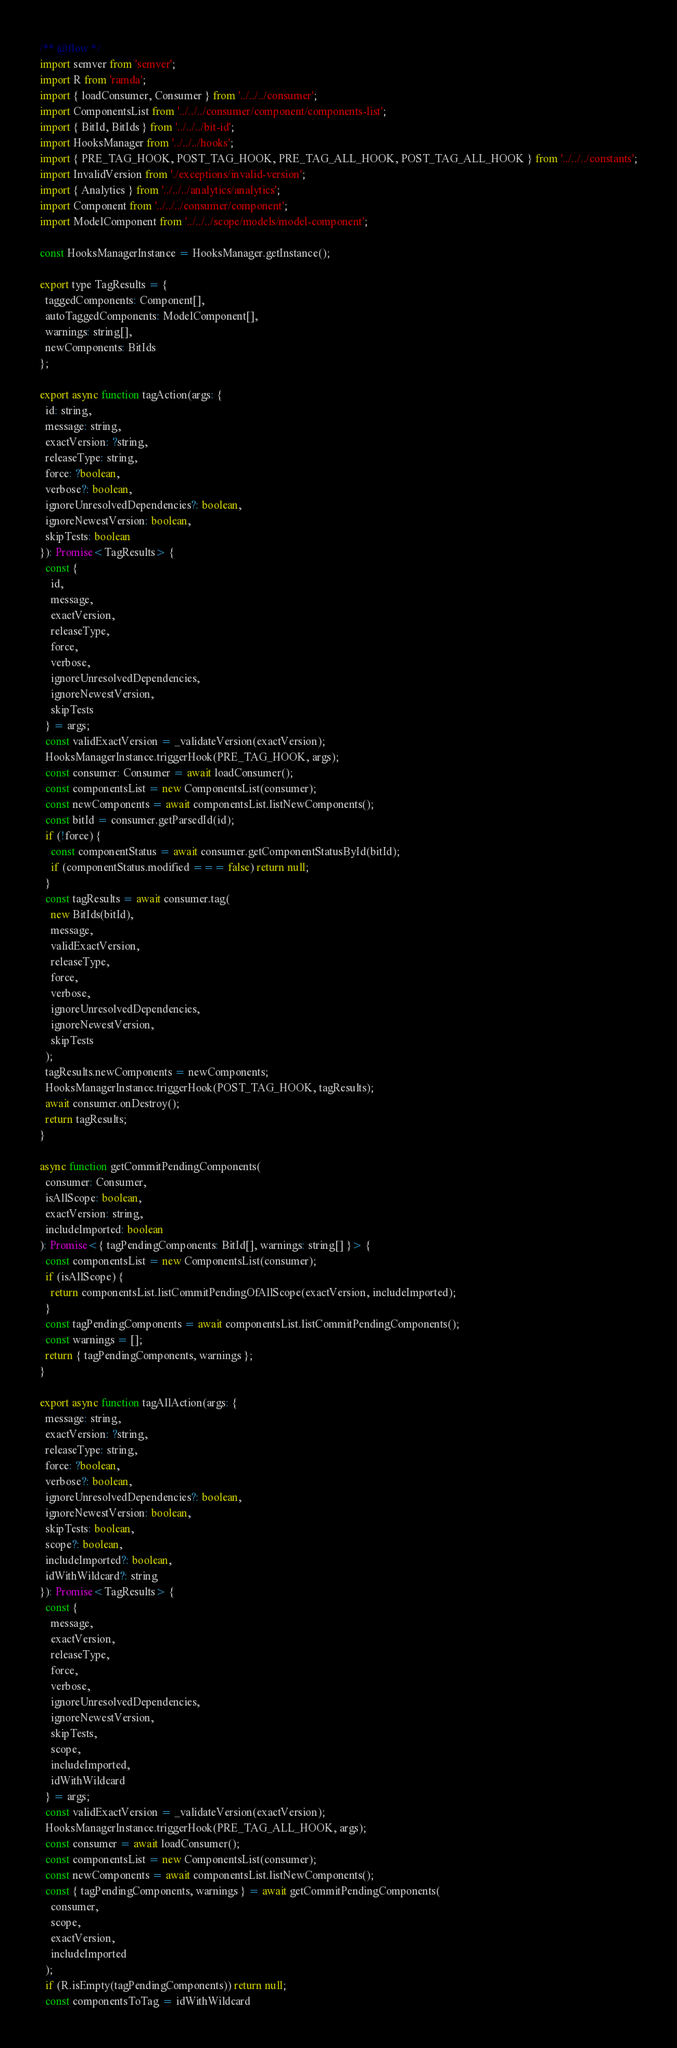Convert code to text. <code><loc_0><loc_0><loc_500><loc_500><_JavaScript_>/** @flow */
import semver from 'semver';
import R from 'ramda';
import { loadConsumer, Consumer } from '../../../consumer';
import ComponentsList from '../../../consumer/component/components-list';
import { BitId, BitIds } from '../../../bit-id';
import HooksManager from '../../../hooks';
import { PRE_TAG_HOOK, POST_TAG_HOOK, PRE_TAG_ALL_HOOK, POST_TAG_ALL_HOOK } from '../../../constants';
import InvalidVersion from './exceptions/invalid-version';
import { Analytics } from '../../../analytics/analytics';
import Component from '../../../consumer/component';
import ModelComponent from '../../../scope/models/model-component';

const HooksManagerInstance = HooksManager.getInstance();

export type TagResults = {
  taggedComponents: Component[],
  autoTaggedComponents: ModelComponent[],
  warnings: string[],
  newComponents: BitIds
};

export async function tagAction(args: {
  id: string,
  message: string,
  exactVersion: ?string,
  releaseType: string,
  force: ?boolean,
  verbose?: boolean,
  ignoreUnresolvedDependencies?: boolean,
  ignoreNewestVersion: boolean,
  skipTests: boolean
}): Promise<TagResults> {
  const {
    id,
    message,
    exactVersion,
    releaseType,
    force,
    verbose,
    ignoreUnresolvedDependencies,
    ignoreNewestVersion,
    skipTests
  } = args;
  const validExactVersion = _validateVersion(exactVersion);
  HooksManagerInstance.triggerHook(PRE_TAG_HOOK, args);
  const consumer: Consumer = await loadConsumer();
  const componentsList = new ComponentsList(consumer);
  const newComponents = await componentsList.listNewComponents();
  const bitId = consumer.getParsedId(id);
  if (!force) {
    const componentStatus = await consumer.getComponentStatusById(bitId);
    if (componentStatus.modified === false) return null;
  }
  const tagResults = await consumer.tag(
    new BitIds(bitId),
    message,
    validExactVersion,
    releaseType,
    force,
    verbose,
    ignoreUnresolvedDependencies,
    ignoreNewestVersion,
    skipTests
  );
  tagResults.newComponents = newComponents;
  HooksManagerInstance.triggerHook(POST_TAG_HOOK, tagResults);
  await consumer.onDestroy();
  return tagResults;
}

async function getCommitPendingComponents(
  consumer: Consumer,
  isAllScope: boolean,
  exactVersion: string,
  includeImported: boolean
): Promise<{ tagPendingComponents: BitId[], warnings: string[] }> {
  const componentsList = new ComponentsList(consumer);
  if (isAllScope) {
    return componentsList.listCommitPendingOfAllScope(exactVersion, includeImported);
  }
  const tagPendingComponents = await componentsList.listCommitPendingComponents();
  const warnings = [];
  return { tagPendingComponents, warnings };
}

export async function tagAllAction(args: {
  message: string,
  exactVersion: ?string,
  releaseType: string,
  force: ?boolean,
  verbose?: boolean,
  ignoreUnresolvedDependencies?: boolean,
  ignoreNewestVersion: boolean,
  skipTests: boolean,
  scope?: boolean,
  includeImported?: boolean,
  idWithWildcard?: string
}): Promise<TagResults> {
  const {
    message,
    exactVersion,
    releaseType,
    force,
    verbose,
    ignoreUnresolvedDependencies,
    ignoreNewestVersion,
    skipTests,
    scope,
    includeImported,
    idWithWildcard
  } = args;
  const validExactVersion = _validateVersion(exactVersion);
  HooksManagerInstance.triggerHook(PRE_TAG_ALL_HOOK, args);
  const consumer = await loadConsumer();
  const componentsList = new ComponentsList(consumer);
  const newComponents = await componentsList.listNewComponents();
  const { tagPendingComponents, warnings } = await getCommitPendingComponents(
    consumer,
    scope,
    exactVersion,
    includeImported
  );
  if (R.isEmpty(tagPendingComponents)) return null;
  const componentsToTag = idWithWildcard</code> 